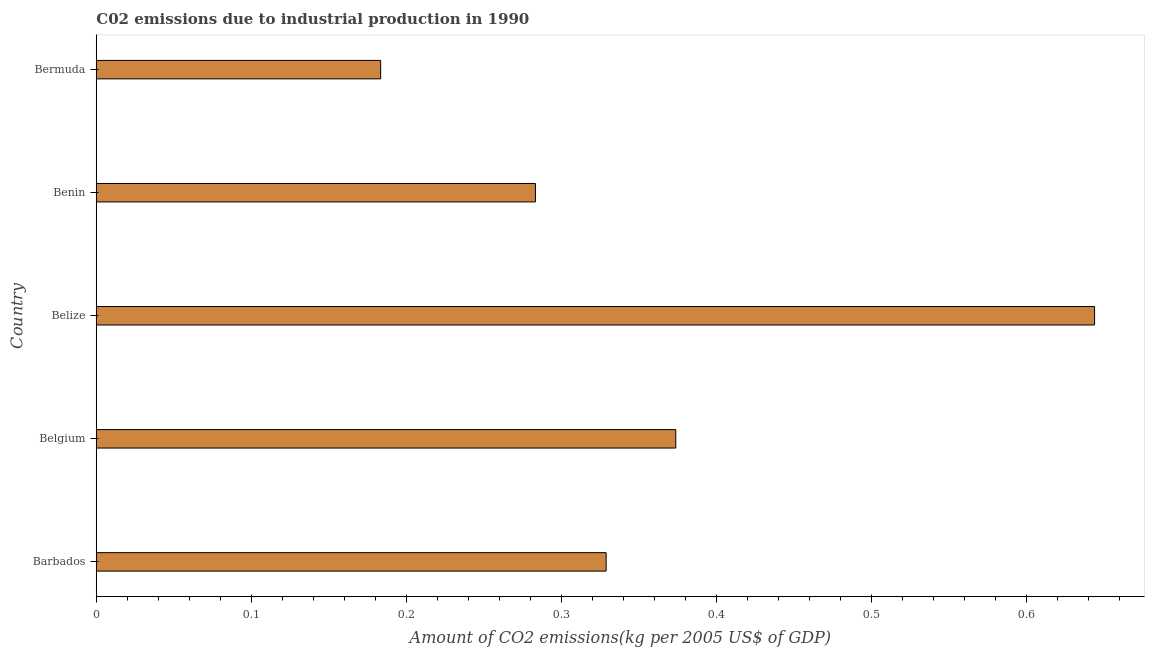Does the graph contain grids?
Ensure brevity in your answer.  No. What is the title of the graph?
Make the answer very short. C02 emissions due to industrial production in 1990. What is the label or title of the X-axis?
Provide a succinct answer. Amount of CO2 emissions(kg per 2005 US$ of GDP). What is the amount of co2 emissions in Bermuda?
Your answer should be compact. 0.18. Across all countries, what is the maximum amount of co2 emissions?
Ensure brevity in your answer.  0.64. Across all countries, what is the minimum amount of co2 emissions?
Provide a succinct answer. 0.18. In which country was the amount of co2 emissions maximum?
Provide a succinct answer. Belize. In which country was the amount of co2 emissions minimum?
Provide a short and direct response. Bermuda. What is the sum of the amount of co2 emissions?
Provide a short and direct response. 1.81. What is the difference between the amount of co2 emissions in Belize and Benin?
Offer a very short reply. 0.36. What is the average amount of co2 emissions per country?
Give a very brief answer. 0.36. What is the median amount of co2 emissions?
Provide a succinct answer. 0.33. In how many countries, is the amount of co2 emissions greater than 0.12 kg per 2005 US$ of GDP?
Make the answer very short. 5. What is the ratio of the amount of co2 emissions in Benin to that in Bermuda?
Provide a succinct answer. 1.54. What is the difference between the highest and the second highest amount of co2 emissions?
Offer a very short reply. 0.27. Is the sum of the amount of co2 emissions in Belgium and Benin greater than the maximum amount of co2 emissions across all countries?
Ensure brevity in your answer.  Yes. What is the difference between the highest and the lowest amount of co2 emissions?
Provide a short and direct response. 0.46. How many bars are there?
Offer a terse response. 5. What is the difference between two consecutive major ticks on the X-axis?
Give a very brief answer. 0.1. Are the values on the major ticks of X-axis written in scientific E-notation?
Ensure brevity in your answer.  No. What is the Amount of CO2 emissions(kg per 2005 US$ of GDP) of Barbados?
Provide a succinct answer. 0.33. What is the Amount of CO2 emissions(kg per 2005 US$ of GDP) of Belgium?
Make the answer very short. 0.37. What is the Amount of CO2 emissions(kg per 2005 US$ of GDP) in Belize?
Provide a succinct answer. 0.64. What is the Amount of CO2 emissions(kg per 2005 US$ of GDP) of Benin?
Keep it short and to the point. 0.28. What is the Amount of CO2 emissions(kg per 2005 US$ of GDP) of Bermuda?
Give a very brief answer. 0.18. What is the difference between the Amount of CO2 emissions(kg per 2005 US$ of GDP) in Barbados and Belgium?
Offer a terse response. -0.04. What is the difference between the Amount of CO2 emissions(kg per 2005 US$ of GDP) in Barbados and Belize?
Provide a succinct answer. -0.32. What is the difference between the Amount of CO2 emissions(kg per 2005 US$ of GDP) in Barbados and Benin?
Your response must be concise. 0.05. What is the difference between the Amount of CO2 emissions(kg per 2005 US$ of GDP) in Barbados and Bermuda?
Give a very brief answer. 0.15. What is the difference between the Amount of CO2 emissions(kg per 2005 US$ of GDP) in Belgium and Belize?
Ensure brevity in your answer.  -0.27. What is the difference between the Amount of CO2 emissions(kg per 2005 US$ of GDP) in Belgium and Benin?
Your answer should be very brief. 0.09. What is the difference between the Amount of CO2 emissions(kg per 2005 US$ of GDP) in Belgium and Bermuda?
Your answer should be very brief. 0.19. What is the difference between the Amount of CO2 emissions(kg per 2005 US$ of GDP) in Belize and Benin?
Give a very brief answer. 0.36. What is the difference between the Amount of CO2 emissions(kg per 2005 US$ of GDP) in Belize and Bermuda?
Your response must be concise. 0.46. What is the difference between the Amount of CO2 emissions(kg per 2005 US$ of GDP) in Benin and Bermuda?
Offer a very short reply. 0.1. What is the ratio of the Amount of CO2 emissions(kg per 2005 US$ of GDP) in Barbados to that in Belize?
Make the answer very short. 0.51. What is the ratio of the Amount of CO2 emissions(kg per 2005 US$ of GDP) in Barbados to that in Benin?
Keep it short and to the point. 1.16. What is the ratio of the Amount of CO2 emissions(kg per 2005 US$ of GDP) in Barbados to that in Bermuda?
Your answer should be very brief. 1.79. What is the ratio of the Amount of CO2 emissions(kg per 2005 US$ of GDP) in Belgium to that in Belize?
Keep it short and to the point. 0.58. What is the ratio of the Amount of CO2 emissions(kg per 2005 US$ of GDP) in Belgium to that in Benin?
Keep it short and to the point. 1.32. What is the ratio of the Amount of CO2 emissions(kg per 2005 US$ of GDP) in Belgium to that in Bermuda?
Ensure brevity in your answer.  2.04. What is the ratio of the Amount of CO2 emissions(kg per 2005 US$ of GDP) in Belize to that in Benin?
Provide a short and direct response. 2.27. What is the ratio of the Amount of CO2 emissions(kg per 2005 US$ of GDP) in Belize to that in Bermuda?
Keep it short and to the point. 3.51. What is the ratio of the Amount of CO2 emissions(kg per 2005 US$ of GDP) in Benin to that in Bermuda?
Offer a very short reply. 1.54. 